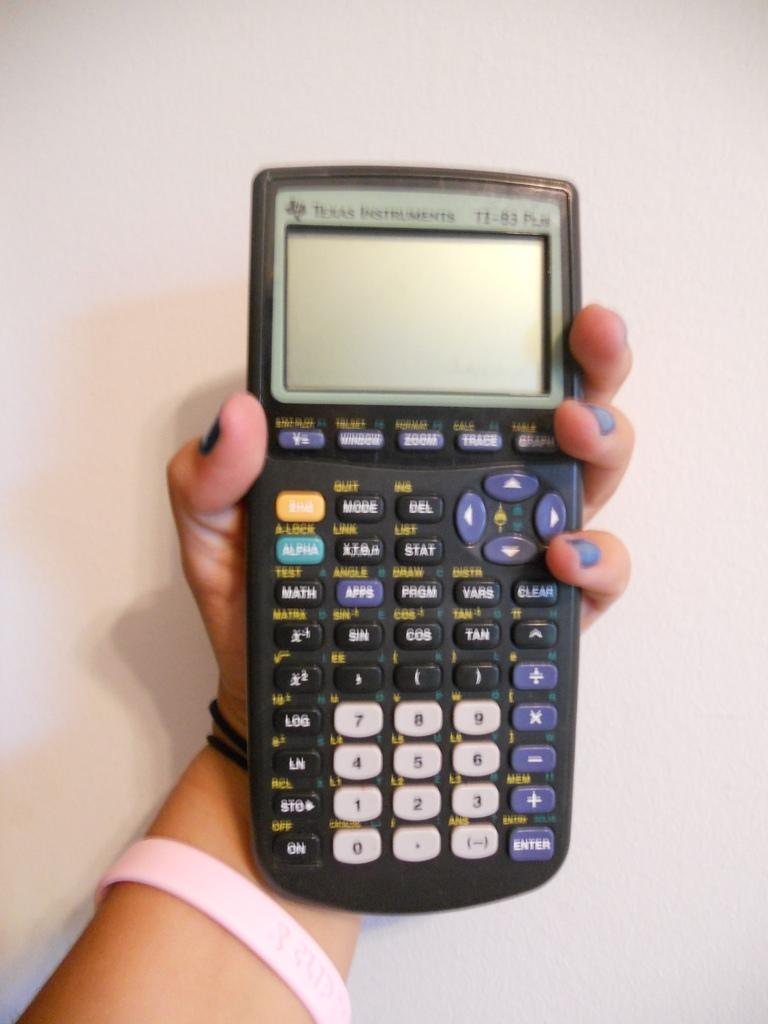Who or what is the main subject in the image? There is a person in the image. What is the person holding in the image? The person is holding a calculator. Can you describe the calculator's features? The calculator has buttons and a screen. What can be seen in the background of the image? There is a wall in the background of the image. What type of brass instrument is the person playing in the image? There is no brass instrument present in the image; the person is holding a calculator. How many friends are visible in the image? There are no friends visible in the image; it only features a person holding a calculator. 